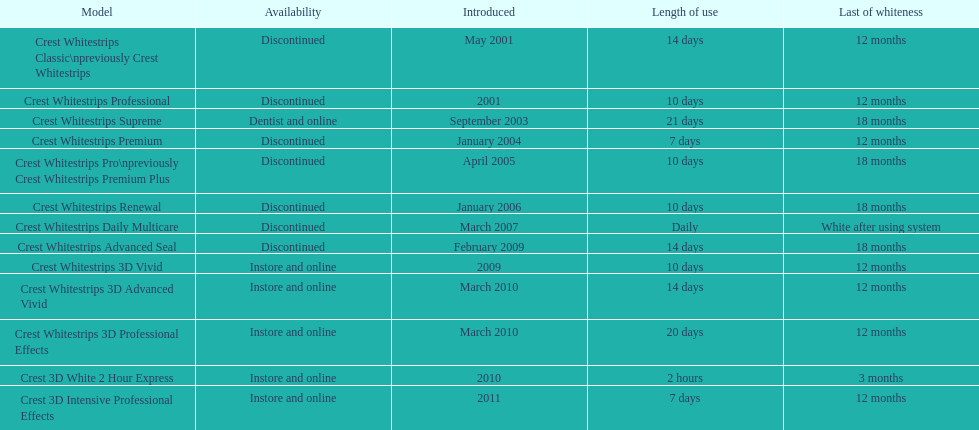What quantity of products made their debut in 2010? 3. 